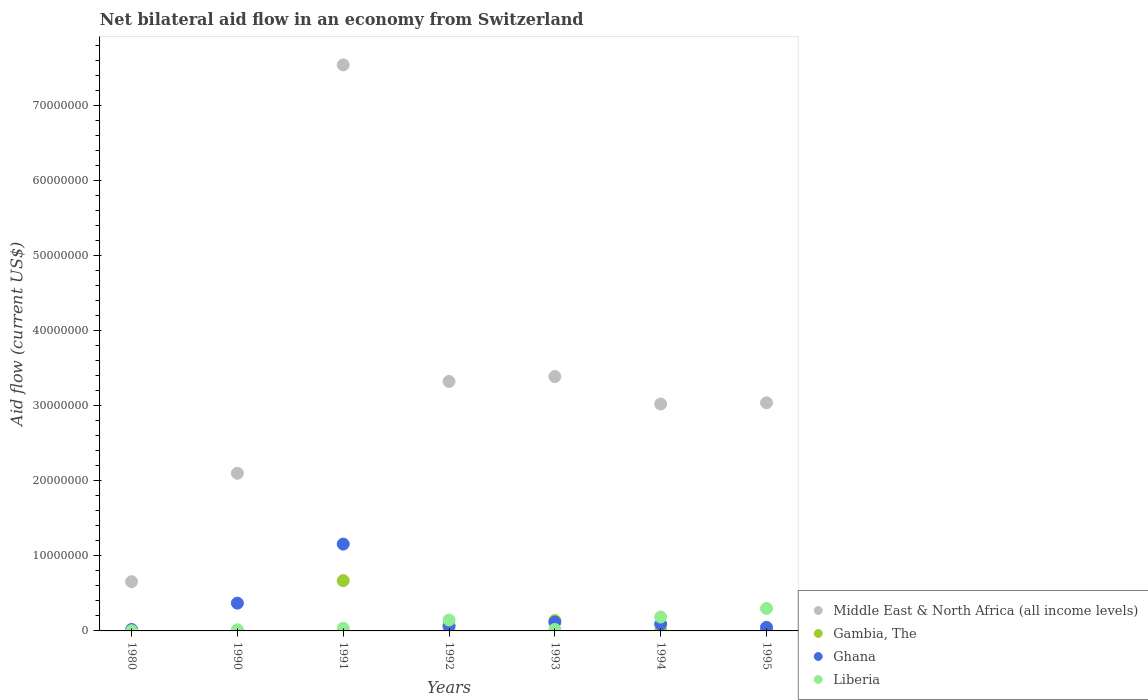Across all years, what is the maximum net bilateral aid flow in Ghana?
Keep it short and to the point. 1.16e+07. Across all years, what is the minimum net bilateral aid flow in Middle East & North Africa (all income levels)?
Your response must be concise. 6.56e+06. What is the total net bilateral aid flow in Middle East & North Africa (all income levels) in the graph?
Ensure brevity in your answer.  2.31e+08. What is the difference between the net bilateral aid flow in Gambia, The in 1980 and that in 1993?
Give a very brief answer. -1.36e+06. What is the difference between the net bilateral aid flow in Middle East & North Africa (all income levels) in 1991 and the net bilateral aid flow in Ghana in 1990?
Provide a short and direct response. 7.17e+07. What is the average net bilateral aid flow in Ghana per year?
Ensure brevity in your answer.  2.67e+06. In the year 1990, what is the difference between the net bilateral aid flow in Ghana and net bilateral aid flow in Gambia, The?
Offer a terse response. 3.66e+06. Is the difference between the net bilateral aid flow in Ghana in 1980 and 1992 greater than the difference between the net bilateral aid flow in Gambia, The in 1980 and 1992?
Your response must be concise. No. What is the difference between the highest and the second highest net bilateral aid flow in Middle East & North Africa (all income levels)?
Offer a terse response. 4.15e+07. What is the difference between the highest and the lowest net bilateral aid flow in Liberia?
Your response must be concise. 2.97e+06. In how many years, is the net bilateral aid flow in Gambia, The greater than the average net bilateral aid flow in Gambia, The taken over all years?
Provide a succinct answer. 2. Is it the case that in every year, the sum of the net bilateral aid flow in Ghana and net bilateral aid flow in Middle East & North Africa (all income levels)  is greater than the sum of net bilateral aid flow in Gambia, The and net bilateral aid flow in Liberia?
Offer a very short reply. Yes. Does the net bilateral aid flow in Liberia monotonically increase over the years?
Keep it short and to the point. No. Is the net bilateral aid flow in Gambia, The strictly less than the net bilateral aid flow in Middle East & North Africa (all income levels) over the years?
Provide a succinct answer. Yes. Are the values on the major ticks of Y-axis written in scientific E-notation?
Keep it short and to the point. No. Does the graph contain any zero values?
Your response must be concise. No. Where does the legend appear in the graph?
Keep it short and to the point. Bottom right. What is the title of the graph?
Keep it short and to the point. Net bilateral aid flow in an economy from Switzerland. Does "Brazil" appear as one of the legend labels in the graph?
Provide a short and direct response. No. What is the label or title of the X-axis?
Make the answer very short. Years. What is the label or title of the Y-axis?
Keep it short and to the point. Aid flow (current US$). What is the Aid flow (current US$) in Middle East & North Africa (all income levels) in 1980?
Your answer should be very brief. 6.56e+06. What is the Aid flow (current US$) of Gambia, The in 1980?
Your answer should be very brief. 2.00e+04. What is the Aid flow (current US$) in Liberia in 1980?
Give a very brief answer. 2.00e+04. What is the Aid flow (current US$) in Middle East & North Africa (all income levels) in 1990?
Your response must be concise. 2.10e+07. What is the Aid flow (current US$) of Ghana in 1990?
Your answer should be compact. 3.70e+06. What is the Aid flow (current US$) in Middle East & North Africa (all income levels) in 1991?
Ensure brevity in your answer.  7.54e+07. What is the Aid flow (current US$) of Gambia, The in 1991?
Offer a very short reply. 6.70e+06. What is the Aid flow (current US$) in Ghana in 1991?
Provide a short and direct response. 1.16e+07. What is the Aid flow (current US$) in Liberia in 1991?
Your answer should be very brief. 3.50e+05. What is the Aid flow (current US$) in Middle East & North Africa (all income levels) in 1992?
Your answer should be compact. 3.32e+07. What is the Aid flow (current US$) of Gambia, The in 1992?
Ensure brevity in your answer.  5.10e+05. What is the Aid flow (current US$) of Ghana in 1992?
Ensure brevity in your answer.  6.80e+05. What is the Aid flow (current US$) of Liberia in 1992?
Your answer should be compact. 1.45e+06. What is the Aid flow (current US$) in Middle East & North Africa (all income levels) in 1993?
Offer a very short reply. 3.39e+07. What is the Aid flow (current US$) of Gambia, The in 1993?
Give a very brief answer. 1.38e+06. What is the Aid flow (current US$) in Ghana in 1993?
Offer a terse response. 1.18e+06. What is the Aid flow (current US$) in Liberia in 1993?
Your answer should be compact. 1.90e+05. What is the Aid flow (current US$) in Middle East & North Africa (all income levels) in 1994?
Offer a very short reply. 3.02e+07. What is the Aid flow (current US$) in Ghana in 1994?
Offer a very short reply. 9.00e+05. What is the Aid flow (current US$) of Liberia in 1994?
Make the answer very short. 1.85e+06. What is the Aid flow (current US$) of Middle East & North Africa (all income levels) in 1995?
Provide a succinct answer. 3.04e+07. What is the Aid flow (current US$) of Ghana in 1995?
Provide a short and direct response. 4.80e+05. What is the Aid flow (current US$) in Liberia in 1995?
Offer a terse response. 2.99e+06. Across all years, what is the maximum Aid flow (current US$) in Middle East & North Africa (all income levels)?
Provide a short and direct response. 7.54e+07. Across all years, what is the maximum Aid flow (current US$) in Gambia, The?
Give a very brief answer. 6.70e+06. Across all years, what is the maximum Aid flow (current US$) in Ghana?
Offer a very short reply. 1.16e+07. Across all years, what is the maximum Aid flow (current US$) of Liberia?
Your response must be concise. 2.99e+06. Across all years, what is the minimum Aid flow (current US$) in Middle East & North Africa (all income levels)?
Give a very brief answer. 6.56e+06. Across all years, what is the minimum Aid flow (current US$) of Gambia, The?
Give a very brief answer. 2.00e+04. Across all years, what is the minimum Aid flow (current US$) in Ghana?
Keep it short and to the point. 1.90e+05. Across all years, what is the minimum Aid flow (current US$) in Liberia?
Keep it short and to the point. 2.00e+04. What is the total Aid flow (current US$) in Middle East & North Africa (all income levels) in the graph?
Keep it short and to the point. 2.31e+08. What is the total Aid flow (current US$) of Gambia, The in the graph?
Your response must be concise. 8.74e+06. What is the total Aid flow (current US$) of Ghana in the graph?
Your answer should be compact. 1.87e+07. What is the total Aid flow (current US$) of Liberia in the graph?
Your answer should be compact. 7.00e+06. What is the difference between the Aid flow (current US$) of Middle East & North Africa (all income levels) in 1980 and that in 1990?
Give a very brief answer. -1.44e+07. What is the difference between the Aid flow (current US$) in Ghana in 1980 and that in 1990?
Offer a very short reply. -3.51e+06. What is the difference between the Aid flow (current US$) of Middle East & North Africa (all income levels) in 1980 and that in 1991?
Offer a terse response. -6.89e+07. What is the difference between the Aid flow (current US$) in Gambia, The in 1980 and that in 1991?
Your answer should be very brief. -6.68e+06. What is the difference between the Aid flow (current US$) of Ghana in 1980 and that in 1991?
Ensure brevity in your answer.  -1.14e+07. What is the difference between the Aid flow (current US$) in Liberia in 1980 and that in 1991?
Your answer should be compact. -3.30e+05. What is the difference between the Aid flow (current US$) of Middle East & North Africa (all income levels) in 1980 and that in 1992?
Give a very brief answer. -2.67e+07. What is the difference between the Aid flow (current US$) of Gambia, The in 1980 and that in 1992?
Offer a very short reply. -4.90e+05. What is the difference between the Aid flow (current US$) of Ghana in 1980 and that in 1992?
Your response must be concise. -4.90e+05. What is the difference between the Aid flow (current US$) in Liberia in 1980 and that in 1992?
Offer a terse response. -1.43e+06. What is the difference between the Aid flow (current US$) in Middle East & North Africa (all income levels) in 1980 and that in 1993?
Your response must be concise. -2.73e+07. What is the difference between the Aid flow (current US$) of Gambia, The in 1980 and that in 1993?
Offer a very short reply. -1.36e+06. What is the difference between the Aid flow (current US$) in Ghana in 1980 and that in 1993?
Your answer should be very brief. -9.90e+05. What is the difference between the Aid flow (current US$) in Middle East & North Africa (all income levels) in 1980 and that in 1994?
Your answer should be compact. -2.37e+07. What is the difference between the Aid flow (current US$) in Gambia, The in 1980 and that in 1994?
Make the answer very short. -2.00e+04. What is the difference between the Aid flow (current US$) in Ghana in 1980 and that in 1994?
Your response must be concise. -7.10e+05. What is the difference between the Aid flow (current US$) in Liberia in 1980 and that in 1994?
Offer a very short reply. -1.83e+06. What is the difference between the Aid flow (current US$) in Middle East & North Africa (all income levels) in 1980 and that in 1995?
Provide a succinct answer. -2.38e+07. What is the difference between the Aid flow (current US$) of Ghana in 1980 and that in 1995?
Ensure brevity in your answer.  -2.90e+05. What is the difference between the Aid flow (current US$) in Liberia in 1980 and that in 1995?
Offer a terse response. -2.97e+06. What is the difference between the Aid flow (current US$) of Middle East & North Africa (all income levels) in 1990 and that in 1991?
Give a very brief answer. -5.44e+07. What is the difference between the Aid flow (current US$) of Gambia, The in 1990 and that in 1991?
Give a very brief answer. -6.66e+06. What is the difference between the Aid flow (current US$) in Ghana in 1990 and that in 1991?
Keep it short and to the point. -7.87e+06. What is the difference between the Aid flow (current US$) of Middle East & North Africa (all income levels) in 1990 and that in 1992?
Offer a terse response. -1.22e+07. What is the difference between the Aid flow (current US$) of Gambia, The in 1990 and that in 1992?
Offer a terse response. -4.70e+05. What is the difference between the Aid flow (current US$) of Ghana in 1990 and that in 1992?
Provide a succinct answer. 3.02e+06. What is the difference between the Aid flow (current US$) in Liberia in 1990 and that in 1992?
Provide a short and direct response. -1.30e+06. What is the difference between the Aid flow (current US$) in Middle East & North Africa (all income levels) in 1990 and that in 1993?
Ensure brevity in your answer.  -1.29e+07. What is the difference between the Aid flow (current US$) of Gambia, The in 1990 and that in 1993?
Your answer should be very brief. -1.34e+06. What is the difference between the Aid flow (current US$) of Ghana in 1990 and that in 1993?
Your answer should be very brief. 2.52e+06. What is the difference between the Aid flow (current US$) of Liberia in 1990 and that in 1993?
Ensure brevity in your answer.  -4.00e+04. What is the difference between the Aid flow (current US$) of Middle East & North Africa (all income levels) in 1990 and that in 1994?
Keep it short and to the point. -9.22e+06. What is the difference between the Aid flow (current US$) in Ghana in 1990 and that in 1994?
Your response must be concise. 2.80e+06. What is the difference between the Aid flow (current US$) in Liberia in 1990 and that in 1994?
Offer a very short reply. -1.70e+06. What is the difference between the Aid flow (current US$) of Middle East & North Africa (all income levels) in 1990 and that in 1995?
Keep it short and to the point. -9.39e+06. What is the difference between the Aid flow (current US$) in Ghana in 1990 and that in 1995?
Your answer should be very brief. 3.22e+06. What is the difference between the Aid flow (current US$) in Liberia in 1990 and that in 1995?
Keep it short and to the point. -2.84e+06. What is the difference between the Aid flow (current US$) in Middle East & North Africa (all income levels) in 1991 and that in 1992?
Keep it short and to the point. 4.22e+07. What is the difference between the Aid flow (current US$) of Gambia, The in 1991 and that in 1992?
Give a very brief answer. 6.19e+06. What is the difference between the Aid flow (current US$) of Ghana in 1991 and that in 1992?
Your response must be concise. 1.09e+07. What is the difference between the Aid flow (current US$) of Liberia in 1991 and that in 1992?
Offer a terse response. -1.10e+06. What is the difference between the Aid flow (current US$) of Middle East & North Africa (all income levels) in 1991 and that in 1993?
Your response must be concise. 4.15e+07. What is the difference between the Aid flow (current US$) in Gambia, The in 1991 and that in 1993?
Keep it short and to the point. 5.32e+06. What is the difference between the Aid flow (current US$) of Ghana in 1991 and that in 1993?
Ensure brevity in your answer.  1.04e+07. What is the difference between the Aid flow (current US$) of Middle East & North Africa (all income levels) in 1991 and that in 1994?
Give a very brief answer. 4.52e+07. What is the difference between the Aid flow (current US$) of Gambia, The in 1991 and that in 1994?
Offer a terse response. 6.66e+06. What is the difference between the Aid flow (current US$) in Ghana in 1991 and that in 1994?
Keep it short and to the point. 1.07e+07. What is the difference between the Aid flow (current US$) in Liberia in 1991 and that in 1994?
Offer a very short reply. -1.50e+06. What is the difference between the Aid flow (current US$) in Middle East & North Africa (all income levels) in 1991 and that in 1995?
Offer a terse response. 4.50e+07. What is the difference between the Aid flow (current US$) in Gambia, The in 1991 and that in 1995?
Provide a succinct answer. 6.65e+06. What is the difference between the Aid flow (current US$) in Ghana in 1991 and that in 1995?
Ensure brevity in your answer.  1.11e+07. What is the difference between the Aid flow (current US$) of Liberia in 1991 and that in 1995?
Provide a short and direct response. -2.64e+06. What is the difference between the Aid flow (current US$) in Middle East & North Africa (all income levels) in 1992 and that in 1993?
Offer a terse response. -6.50e+05. What is the difference between the Aid flow (current US$) of Gambia, The in 1992 and that in 1993?
Ensure brevity in your answer.  -8.70e+05. What is the difference between the Aid flow (current US$) of Ghana in 1992 and that in 1993?
Provide a succinct answer. -5.00e+05. What is the difference between the Aid flow (current US$) of Liberia in 1992 and that in 1993?
Give a very brief answer. 1.26e+06. What is the difference between the Aid flow (current US$) in Middle East & North Africa (all income levels) in 1992 and that in 1994?
Offer a terse response. 3.01e+06. What is the difference between the Aid flow (current US$) in Gambia, The in 1992 and that in 1994?
Keep it short and to the point. 4.70e+05. What is the difference between the Aid flow (current US$) in Liberia in 1992 and that in 1994?
Offer a terse response. -4.00e+05. What is the difference between the Aid flow (current US$) in Middle East & North Africa (all income levels) in 1992 and that in 1995?
Give a very brief answer. 2.84e+06. What is the difference between the Aid flow (current US$) of Gambia, The in 1992 and that in 1995?
Make the answer very short. 4.60e+05. What is the difference between the Aid flow (current US$) in Liberia in 1992 and that in 1995?
Provide a short and direct response. -1.54e+06. What is the difference between the Aid flow (current US$) in Middle East & North Africa (all income levels) in 1993 and that in 1994?
Your response must be concise. 3.66e+06. What is the difference between the Aid flow (current US$) in Gambia, The in 1993 and that in 1994?
Your answer should be compact. 1.34e+06. What is the difference between the Aid flow (current US$) of Liberia in 1993 and that in 1994?
Offer a very short reply. -1.66e+06. What is the difference between the Aid flow (current US$) in Middle East & North Africa (all income levels) in 1993 and that in 1995?
Provide a short and direct response. 3.49e+06. What is the difference between the Aid flow (current US$) in Gambia, The in 1993 and that in 1995?
Make the answer very short. 1.33e+06. What is the difference between the Aid flow (current US$) of Ghana in 1993 and that in 1995?
Provide a succinct answer. 7.00e+05. What is the difference between the Aid flow (current US$) of Liberia in 1993 and that in 1995?
Your answer should be compact. -2.80e+06. What is the difference between the Aid flow (current US$) in Middle East & North Africa (all income levels) in 1994 and that in 1995?
Keep it short and to the point. -1.70e+05. What is the difference between the Aid flow (current US$) of Liberia in 1994 and that in 1995?
Keep it short and to the point. -1.14e+06. What is the difference between the Aid flow (current US$) of Middle East & North Africa (all income levels) in 1980 and the Aid flow (current US$) of Gambia, The in 1990?
Your answer should be compact. 6.52e+06. What is the difference between the Aid flow (current US$) of Middle East & North Africa (all income levels) in 1980 and the Aid flow (current US$) of Ghana in 1990?
Provide a succinct answer. 2.86e+06. What is the difference between the Aid flow (current US$) of Middle East & North Africa (all income levels) in 1980 and the Aid flow (current US$) of Liberia in 1990?
Offer a terse response. 6.41e+06. What is the difference between the Aid flow (current US$) of Gambia, The in 1980 and the Aid flow (current US$) of Ghana in 1990?
Your answer should be compact. -3.68e+06. What is the difference between the Aid flow (current US$) of Gambia, The in 1980 and the Aid flow (current US$) of Liberia in 1990?
Ensure brevity in your answer.  -1.30e+05. What is the difference between the Aid flow (current US$) in Middle East & North Africa (all income levels) in 1980 and the Aid flow (current US$) in Gambia, The in 1991?
Provide a succinct answer. -1.40e+05. What is the difference between the Aid flow (current US$) of Middle East & North Africa (all income levels) in 1980 and the Aid flow (current US$) of Ghana in 1991?
Make the answer very short. -5.01e+06. What is the difference between the Aid flow (current US$) in Middle East & North Africa (all income levels) in 1980 and the Aid flow (current US$) in Liberia in 1991?
Provide a succinct answer. 6.21e+06. What is the difference between the Aid flow (current US$) in Gambia, The in 1980 and the Aid flow (current US$) in Ghana in 1991?
Provide a succinct answer. -1.16e+07. What is the difference between the Aid flow (current US$) in Gambia, The in 1980 and the Aid flow (current US$) in Liberia in 1991?
Provide a short and direct response. -3.30e+05. What is the difference between the Aid flow (current US$) of Middle East & North Africa (all income levels) in 1980 and the Aid flow (current US$) of Gambia, The in 1992?
Your answer should be compact. 6.05e+06. What is the difference between the Aid flow (current US$) of Middle East & North Africa (all income levels) in 1980 and the Aid flow (current US$) of Ghana in 1992?
Keep it short and to the point. 5.88e+06. What is the difference between the Aid flow (current US$) in Middle East & North Africa (all income levels) in 1980 and the Aid flow (current US$) in Liberia in 1992?
Ensure brevity in your answer.  5.11e+06. What is the difference between the Aid flow (current US$) of Gambia, The in 1980 and the Aid flow (current US$) of Ghana in 1992?
Offer a terse response. -6.60e+05. What is the difference between the Aid flow (current US$) of Gambia, The in 1980 and the Aid flow (current US$) of Liberia in 1992?
Your answer should be very brief. -1.43e+06. What is the difference between the Aid flow (current US$) of Ghana in 1980 and the Aid flow (current US$) of Liberia in 1992?
Your answer should be very brief. -1.26e+06. What is the difference between the Aid flow (current US$) in Middle East & North Africa (all income levels) in 1980 and the Aid flow (current US$) in Gambia, The in 1993?
Provide a short and direct response. 5.18e+06. What is the difference between the Aid flow (current US$) of Middle East & North Africa (all income levels) in 1980 and the Aid flow (current US$) of Ghana in 1993?
Your response must be concise. 5.38e+06. What is the difference between the Aid flow (current US$) of Middle East & North Africa (all income levels) in 1980 and the Aid flow (current US$) of Liberia in 1993?
Ensure brevity in your answer.  6.37e+06. What is the difference between the Aid flow (current US$) of Gambia, The in 1980 and the Aid flow (current US$) of Ghana in 1993?
Your answer should be very brief. -1.16e+06. What is the difference between the Aid flow (current US$) of Middle East & North Africa (all income levels) in 1980 and the Aid flow (current US$) of Gambia, The in 1994?
Offer a terse response. 6.52e+06. What is the difference between the Aid flow (current US$) in Middle East & North Africa (all income levels) in 1980 and the Aid flow (current US$) in Ghana in 1994?
Offer a very short reply. 5.66e+06. What is the difference between the Aid flow (current US$) of Middle East & North Africa (all income levels) in 1980 and the Aid flow (current US$) of Liberia in 1994?
Make the answer very short. 4.71e+06. What is the difference between the Aid flow (current US$) in Gambia, The in 1980 and the Aid flow (current US$) in Ghana in 1994?
Provide a short and direct response. -8.80e+05. What is the difference between the Aid flow (current US$) in Gambia, The in 1980 and the Aid flow (current US$) in Liberia in 1994?
Keep it short and to the point. -1.83e+06. What is the difference between the Aid flow (current US$) of Ghana in 1980 and the Aid flow (current US$) of Liberia in 1994?
Offer a terse response. -1.66e+06. What is the difference between the Aid flow (current US$) of Middle East & North Africa (all income levels) in 1980 and the Aid flow (current US$) of Gambia, The in 1995?
Make the answer very short. 6.51e+06. What is the difference between the Aid flow (current US$) of Middle East & North Africa (all income levels) in 1980 and the Aid flow (current US$) of Ghana in 1995?
Ensure brevity in your answer.  6.08e+06. What is the difference between the Aid flow (current US$) of Middle East & North Africa (all income levels) in 1980 and the Aid flow (current US$) of Liberia in 1995?
Offer a very short reply. 3.57e+06. What is the difference between the Aid flow (current US$) of Gambia, The in 1980 and the Aid flow (current US$) of Ghana in 1995?
Provide a short and direct response. -4.60e+05. What is the difference between the Aid flow (current US$) of Gambia, The in 1980 and the Aid flow (current US$) of Liberia in 1995?
Make the answer very short. -2.97e+06. What is the difference between the Aid flow (current US$) of Ghana in 1980 and the Aid flow (current US$) of Liberia in 1995?
Your answer should be compact. -2.80e+06. What is the difference between the Aid flow (current US$) in Middle East & North Africa (all income levels) in 1990 and the Aid flow (current US$) in Gambia, The in 1991?
Offer a very short reply. 1.43e+07. What is the difference between the Aid flow (current US$) in Middle East & North Africa (all income levels) in 1990 and the Aid flow (current US$) in Ghana in 1991?
Offer a very short reply. 9.44e+06. What is the difference between the Aid flow (current US$) in Middle East & North Africa (all income levels) in 1990 and the Aid flow (current US$) in Liberia in 1991?
Offer a terse response. 2.07e+07. What is the difference between the Aid flow (current US$) of Gambia, The in 1990 and the Aid flow (current US$) of Ghana in 1991?
Provide a succinct answer. -1.15e+07. What is the difference between the Aid flow (current US$) in Gambia, The in 1990 and the Aid flow (current US$) in Liberia in 1991?
Ensure brevity in your answer.  -3.10e+05. What is the difference between the Aid flow (current US$) in Ghana in 1990 and the Aid flow (current US$) in Liberia in 1991?
Offer a terse response. 3.35e+06. What is the difference between the Aid flow (current US$) in Middle East & North Africa (all income levels) in 1990 and the Aid flow (current US$) in Gambia, The in 1992?
Make the answer very short. 2.05e+07. What is the difference between the Aid flow (current US$) in Middle East & North Africa (all income levels) in 1990 and the Aid flow (current US$) in Ghana in 1992?
Your answer should be compact. 2.03e+07. What is the difference between the Aid flow (current US$) of Middle East & North Africa (all income levels) in 1990 and the Aid flow (current US$) of Liberia in 1992?
Give a very brief answer. 1.96e+07. What is the difference between the Aid flow (current US$) in Gambia, The in 1990 and the Aid flow (current US$) in Ghana in 1992?
Your response must be concise. -6.40e+05. What is the difference between the Aid flow (current US$) in Gambia, The in 1990 and the Aid flow (current US$) in Liberia in 1992?
Your answer should be compact. -1.41e+06. What is the difference between the Aid flow (current US$) in Ghana in 1990 and the Aid flow (current US$) in Liberia in 1992?
Make the answer very short. 2.25e+06. What is the difference between the Aid flow (current US$) in Middle East & North Africa (all income levels) in 1990 and the Aid flow (current US$) in Gambia, The in 1993?
Your answer should be very brief. 1.96e+07. What is the difference between the Aid flow (current US$) in Middle East & North Africa (all income levels) in 1990 and the Aid flow (current US$) in Ghana in 1993?
Provide a succinct answer. 1.98e+07. What is the difference between the Aid flow (current US$) of Middle East & North Africa (all income levels) in 1990 and the Aid flow (current US$) of Liberia in 1993?
Make the answer very short. 2.08e+07. What is the difference between the Aid flow (current US$) of Gambia, The in 1990 and the Aid flow (current US$) of Ghana in 1993?
Provide a short and direct response. -1.14e+06. What is the difference between the Aid flow (current US$) of Ghana in 1990 and the Aid flow (current US$) of Liberia in 1993?
Your response must be concise. 3.51e+06. What is the difference between the Aid flow (current US$) in Middle East & North Africa (all income levels) in 1990 and the Aid flow (current US$) in Gambia, The in 1994?
Provide a succinct answer. 2.10e+07. What is the difference between the Aid flow (current US$) in Middle East & North Africa (all income levels) in 1990 and the Aid flow (current US$) in Ghana in 1994?
Make the answer very short. 2.01e+07. What is the difference between the Aid flow (current US$) in Middle East & North Africa (all income levels) in 1990 and the Aid flow (current US$) in Liberia in 1994?
Make the answer very short. 1.92e+07. What is the difference between the Aid flow (current US$) of Gambia, The in 1990 and the Aid flow (current US$) of Ghana in 1994?
Give a very brief answer. -8.60e+05. What is the difference between the Aid flow (current US$) of Gambia, The in 1990 and the Aid flow (current US$) of Liberia in 1994?
Make the answer very short. -1.81e+06. What is the difference between the Aid flow (current US$) in Ghana in 1990 and the Aid flow (current US$) in Liberia in 1994?
Offer a terse response. 1.85e+06. What is the difference between the Aid flow (current US$) of Middle East & North Africa (all income levels) in 1990 and the Aid flow (current US$) of Gambia, The in 1995?
Your answer should be compact. 2.10e+07. What is the difference between the Aid flow (current US$) in Middle East & North Africa (all income levels) in 1990 and the Aid flow (current US$) in Ghana in 1995?
Make the answer very short. 2.05e+07. What is the difference between the Aid flow (current US$) of Middle East & North Africa (all income levels) in 1990 and the Aid flow (current US$) of Liberia in 1995?
Offer a terse response. 1.80e+07. What is the difference between the Aid flow (current US$) of Gambia, The in 1990 and the Aid flow (current US$) of Ghana in 1995?
Your answer should be very brief. -4.40e+05. What is the difference between the Aid flow (current US$) of Gambia, The in 1990 and the Aid flow (current US$) of Liberia in 1995?
Provide a succinct answer. -2.95e+06. What is the difference between the Aid flow (current US$) of Ghana in 1990 and the Aid flow (current US$) of Liberia in 1995?
Your answer should be compact. 7.10e+05. What is the difference between the Aid flow (current US$) in Middle East & North Africa (all income levels) in 1991 and the Aid flow (current US$) in Gambia, The in 1992?
Your answer should be compact. 7.49e+07. What is the difference between the Aid flow (current US$) in Middle East & North Africa (all income levels) in 1991 and the Aid flow (current US$) in Ghana in 1992?
Ensure brevity in your answer.  7.47e+07. What is the difference between the Aid flow (current US$) in Middle East & North Africa (all income levels) in 1991 and the Aid flow (current US$) in Liberia in 1992?
Offer a terse response. 7.40e+07. What is the difference between the Aid flow (current US$) of Gambia, The in 1991 and the Aid flow (current US$) of Ghana in 1992?
Provide a short and direct response. 6.02e+06. What is the difference between the Aid flow (current US$) of Gambia, The in 1991 and the Aid flow (current US$) of Liberia in 1992?
Make the answer very short. 5.25e+06. What is the difference between the Aid flow (current US$) in Ghana in 1991 and the Aid flow (current US$) in Liberia in 1992?
Keep it short and to the point. 1.01e+07. What is the difference between the Aid flow (current US$) in Middle East & North Africa (all income levels) in 1991 and the Aid flow (current US$) in Gambia, The in 1993?
Ensure brevity in your answer.  7.40e+07. What is the difference between the Aid flow (current US$) in Middle East & North Africa (all income levels) in 1991 and the Aid flow (current US$) in Ghana in 1993?
Ensure brevity in your answer.  7.42e+07. What is the difference between the Aid flow (current US$) in Middle East & North Africa (all income levels) in 1991 and the Aid flow (current US$) in Liberia in 1993?
Keep it short and to the point. 7.52e+07. What is the difference between the Aid flow (current US$) of Gambia, The in 1991 and the Aid flow (current US$) of Ghana in 1993?
Offer a very short reply. 5.52e+06. What is the difference between the Aid flow (current US$) in Gambia, The in 1991 and the Aid flow (current US$) in Liberia in 1993?
Make the answer very short. 6.51e+06. What is the difference between the Aid flow (current US$) in Ghana in 1991 and the Aid flow (current US$) in Liberia in 1993?
Your answer should be compact. 1.14e+07. What is the difference between the Aid flow (current US$) in Middle East & North Africa (all income levels) in 1991 and the Aid flow (current US$) in Gambia, The in 1994?
Ensure brevity in your answer.  7.54e+07. What is the difference between the Aid flow (current US$) of Middle East & North Africa (all income levels) in 1991 and the Aid flow (current US$) of Ghana in 1994?
Ensure brevity in your answer.  7.45e+07. What is the difference between the Aid flow (current US$) of Middle East & North Africa (all income levels) in 1991 and the Aid flow (current US$) of Liberia in 1994?
Offer a terse response. 7.36e+07. What is the difference between the Aid flow (current US$) in Gambia, The in 1991 and the Aid flow (current US$) in Ghana in 1994?
Your response must be concise. 5.80e+06. What is the difference between the Aid flow (current US$) of Gambia, The in 1991 and the Aid flow (current US$) of Liberia in 1994?
Provide a succinct answer. 4.85e+06. What is the difference between the Aid flow (current US$) of Ghana in 1991 and the Aid flow (current US$) of Liberia in 1994?
Make the answer very short. 9.72e+06. What is the difference between the Aid flow (current US$) in Middle East & North Africa (all income levels) in 1991 and the Aid flow (current US$) in Gambia, The in 1995?
Your answer should be compact. 7.54e+07. What is the difference between the Aid flow (current US$) of Middle East & North Africa (all income levels) in 1991 and the Aid flow (current US$) of Ghana in 1995?
Make the answer very short. 7.49e+07. What is the difference between the Aid flow (current US$) of Middle East & North Africa (all income levels) in 1991 and the Aid flow (current US$) of Liberia in 1995?
Offer a very short reply. 7.24e+07. What is the difference between the Aid flow (current US$) in Gambia, The in 1991 and the Aid flow (current US$) in Ghana in 1995?
Provide a succinct answer. 6.22e+06. What is the difference between the Aid flow (current US$) in Gambia, The in 1991 and the Aid flow (current US$) in Liberia in 1995?
Provide a short and direct response. 3.71e+06. What is the difference between the Aid flow (current US$) in Ghana in 1991 and the Aid flow (current US$) in Liberia in 1995?
Provide a short and direct response. 8.58e+06. What is the difference between the Aid flow (current US$) in Middle East & North Africa (all income levels) in 1992 and the Aid flow (current US$) in Gambia, The in 1993?
Offer a terse response. 3.19e+07. What is the difference between the Aid flow (current US$) in Middle East & North Africa (all income levels) in 1992 and the Aid flow (current US$) in Ghana in 1993?
Your answer should be very brief. 3.21e+07. What is the difference between the Aid flow (current US$) in Middle East & North Africa (all income levels) in 1992 and the Aid flow (current US$) in Liberia in 1993?
Your answer should be compact. 3.30e+07. What is the difference between the Aid flow (current US$) of Gambia, The in 1992 and the Aid flow (current US$) of Ghana in 1993?
Give a very brief answer. -6.70e+05. What is the difference between the Aid flow (current US$) of Gambia, The in 1992 and the Aid flow (current US$) of Liberia in 1993?
Provide a short and direct response. 3.20e+05. What is the difference between the Aid flow (current US$) in Ghana in 1992 and the Aid flow (current US$) in Liberia in 1993?
Provide a succinct answer. 4.90e+05. What is the difference between the Aid flow (current US$) in Middle East & North Africa (all income levels) in 1992 and the Aid flow (current US$) in Gambia, The in 1994?
Ensure brevity in your answer.  3.32e+07. What is the difference between the Aid flow (current US$) in Middle East & North Africa (all income levels) in 1992 and the Aid flow (current US$) in Ghana in 1994?
Offer a terse response. 3.23e+07. What is the difference between the Aid flow (current US$) of Middle East & North Africa (all income levels) in 1992 and the Aid flow (current US$) of Liberia in 1994?
Keep it short and to the point. 3.14e+07. What is the difference between the Aid flow (current US$) in Gambia, The in 1992 and the Aid flow (current US$) in Ghana in 1994?
Give a very brief answer. -3.90e+05. What is the difference between the Aid flow (current US$) of Gambia, The in 1992 and the Aid flow (current US$) of Liberia in 1994?
Provide a succinct answer. -1.34e+06. What is the difference between the Aid flow (current US$) of Ghana in 1992 and the Aid flow (current US$) of Liberia in 1994?
Your answer should be compact. -1.17e+06. What is the difference between the Aid flow (current US$) of Middle East & North Africa (all income levels) in 1992 and the Aid flow (current US$) of Gambia, The in 1995?
Make the answer very short. 3.32e+07. What is the difference between the Aid flow (current US$) in Middle East & North Africa (all income levels) in 1992 and the Aid flow (current US$) in Ghana in 1995?
Offer a very short reply. 3.28e+07. What is the difference between the Aid flow (current US$) in Middle East & North Africa (all income levels) in 1992 and the Aid flow (current US$) in Liberia in 1995?
Provide a short and direct response. 3.02e+07. What is the difference between the Aid flow (current US$) in Gambia, The in 1992 and the Aid flow (current US$) in Ghana in 1995?
Ensure brevity in your answer.  3.00e+04. What is the difference between the Aid flow (current US$) in Gambia, The in 1992 and the Aid flow (current US$) in Liberia in 1995?
Give a very brief answer. -2.48e+06. What is the difference between the Aid flow (current US$) of Ghana in 1992 and the Aid flow (current US$) of Liberia in 1995?
Your response must be concise. -2.31e+06. What is the difference between the Aid flow (current US$) in Middle East & North Africa (all income levels) in 1993 and the Aid flow (current US$) in Gambia, The in 1994?
Ensure brevity in your answer.  3.38e+07. What is the difference between the Aid flow (current US$) in Middle East & North Africa (all income levels) in 1993 and the Aid flow (current US$) in Ghana in 1994?
Provide a short and direct response. 3.30e+07. What is the difference between the Aid flow (current US$) of Middle East & North Africa (all income levels) in 1993 and the Aid flow (current US$) of Liberia in 1994?
Provide a succinct answer. 3.20e+07. What is the difference between the Aid flow (current US$) of Gambia, The in 1993 and the Aid flow (current US$) of Liberia in 1994?
Provide a succinct answer. -4.70e+05. What is the difference between the Aid flow (current US$) in Ghana in 1993 and the Aid flow (current US$) in Liberia in 1994?
Your response must be concise. -6.70e+05. What is the difference between the Aid flow (current US$) in Middle East & North Africa (all income levels) in 1993 and the Aid flow (current US$) in Gambia, The in 1995?
Give a very brief answer. 3.38e+07. What is the difference between the Aid flow (current US$) in Middle East & North Africa (all income levels) in 1993 and the Aid flow (current US$) in Ghana in 1995?
Ensure brevity in your answer.  3.34e+07. What is the difference between the Aid flow (current US$) of Middle East & North Africa (all income levels) in 1993 and the Aid flow (current US$) of Liberia in 1995?
Offer a very short reply. 3.09e+07. What is the difference between the Aid flow (current US$) in Gambia, The in 1993 and the Aid flow (current US$) in Liberia in 1995?
Keep it short and to the point. -1.61e+06. What is the difference between the Aid flow (current US$) of Ghana in 1993 and the Aid flow (current US$) of Liberia in 1995?
Ensure brevity in your answer.  -1.81e+06. What is the difference between the Aid flow (current US$) of Middle East & North Africa (all income levels) in 1994 and the Aid flow (current US$) of Gambia, The in 1995?
Give a very brief answer. 3.02e+07. What is the difference between the Aid flow (current US$) in Middle East & North Africa (all income levels) in 1994 and the Aid flow (current US$) in Ghana in 1995?
Offer a terse response. 2.98e+07. What is the difference between the Aid flow (current US$) of Middle East & North Africa (all income levels) in 1994 and the Aid flow (current US$) of Liberia in 1995?
Ensure brevity in your answer.  2.72e+07. What is the difference between the Aid flow (current US$) of Gambia, The in 1994 and the Aid flow (current US$) of Ghana in 1995?
Your answer should be compact. -4.40e+05. What is the difference between the Aid flow (current US$) in Gambia, The in 1994 and the Aid flow (current US$) in Liberia in 1995?
Offer a terse response. -2.95e+06. What is the difference between the Aid flow (current US$) of Ghana in 1994 and the Aid flow (current US$) of Liberia in 1995?
Make the answer very short. -2.09e+06. What is the average Aid flow (current US$) of Middle East & North Africa (all income levels) per year?
Your answer should be very brief. 3.30e+07. What is the average Aid flow (current US$) in Gambia, The per year?
Provide a succinct answer. 1.25e+06. What is the average Aid flow (current US$) in Ghana per year?
Give a very brief answer. 2.67e+06. What is the average Aid flow (current US$) in Liberia per year?
Provide a short and direct response. 1.00e+06. In the year 1980, what is the difference between the Aid flow (current US$) in Middle East & North Africa (all income levels) and Aid flow (current US$) in Gambia, The?
Your response must be concise. 6.54e+06. In the year 1980, what is the difference between the Aid flow (current US$) in Middle East & North Africa (all income levels) and Aid flow (current US$) in Ghana?
Make the answer very short. 6.37e+06. In the year 1980, what is the difference between the Aid flow (current US$) in Middle East & North Africa (all income levels) and Aid flow (current US$) in Liberia?
Your answer should be compact. 6.54e+06. In the year 1980, what is the difference between the Aid flow (current US$) of Gambia, The and Aid flow (current US$) of Liberia?
Offer a terse response. 0. In the year 1990, what is the difference between the Aid flow (current US$) in Middle East & North Africa (all income levels) and Aid flow (current US$) in Gambia, The?
Ensure brevity in your answer.  2.10e+07. In the year 1990, what is the difference between the Aid flow (current US$) in Middle East & North Africa (all income levels) and Aid flow (current US$) in Ghana?
Ensure brevity in your answer.  1.73e+07. In the year 1990, what is the difference between the Aid flow (current US$) in Middle East & North Africa (all income levels) and Aid flow (current US$) in Liberia?
Provide a succinct answer. 2.09e+07. In the year 1990, what is the difference between the Aid flow (current US$) of Gambia, The and Aid flow (current US$) of Ghana?
Provide a short and direct response. -3.66e+06. In the year 1990, what is the difference between the Aid flow (current US$) in Ghana and Aid flow (current US$) in Liberia?
Ensure brevity in your answer.  3.55e+06. In the year 1991, what is the difference between the Aid flow (current US$) of Middle East & North Africa (all income levels) and Aid flow (current US$) of Gambia, The?
Ensure brevity in your answer.  6.87e+07. In the year 1991, what is the difference between the Aid flow (current US$) in Middle East & North Africa (all income levels) and Aid flow (current US$) in Ghana?
Provide a succinct answer. 6.38e+07. In the year 1991, what is the difference between the Aid flow (current US$) in Middle East & North Africa (all income levels) and Aid flow (current US$) in Liberia?
Ensure brevity in your answer.  7.51e+07. In the year 1991, what is the difference between the Aid flow (current US$) of Gambia, The and Aid flow (current US$) of Ghana?
Offer a very short reply. -4.87e+06. In the year 1991, what is the difference between the Aid flow (current US$) in Gambia, The and Aid flow (current US$) in Liberia?
Offer a very short reply. 6.35e+06. In the year 1991, what is the difference between the Aid flow (current US$) in Ghana and Aid flow (current US$) in Liberia?
Make the answer very short. 1.12e+07. In the year 1992, what is the difference between the Aid flow (current US$) of Middle East & North Africa (all income levels) and Aid flow (current US$) of Gambia, The?
Your response must be concise. 3.27e+07. In the year 1992, what is the difference between the Aid flow (current US$) of Middle East & North Africa (all income levels) and Aid flow (current US$) of Ghana?
Offer a very short reply. 3.26e+07. In the year 1992, what is the difference between the Aid flow (current US$) of Middle East & North Africa (all income levels) and Aid flow (current US$) of Liberia?
Ensure brevity in your answer.  3.18e+07. In the year 1992, what is the difference between the Aid flow (current US$) in Gambia, The and Aid flow (current US$) in Liberia?
Provide a succinct answer. -9.40e+05. In the year 1992, what is the difference between the Aid flow (current US$) of Ghana and Aid flow (current US$) of Liberia?
Your answer should be very brief. -7.70e+05. In the year 1993, what is the difference between the Aid flow (current US$) of Middle East & North Africa (all income levels) and Aid flow (current US$) of Gambia, The?
Give a very brief answer. 3.25e+07. In the year 1993, what is the difference between the Aid flow (current US$) of Middle East & North Africa (all income levels) and Aid flow (current US$) of Ghana?
Give a very brief answer. 3.27e+07. In the year 1993, what is the difference between the Aid flow (current US$) of Middle East & North Africa (all income levels) and Aid flow (current US$) of Liberia?
Your answer should be very brief. 3.37e+07. In the year 1993, what is the difference between the Aid flow (current US$) of Gambia, The and Aid flow (current US$) of Liberia?
Your response must be concise. 1.19e+06. In the year 1993, what is the difference between the Aid flow (current US$) of Ghana and Aid flow (current US$) of Liberia?
Give a very brief answer. 9.90e+05. In the year 1994, what is the difference between the Aid flow (current US$) in Middle East & North Africa (all income levels) and Aid flow (current US$) in Gambia, The?
Provide a succinct answer. 3.02e+07. In the year 1994, what is the difference between the Aid flow (current US$) in Middle East & North Africa (all income levels) and Aid flow (current US$) in Ghana?
Keep it short and to the point. 2.93e+07. In the year 1994, what is the difference between the Aid flow (current US$) in Middle East & North Africa (all income levels) and Aid flow (current US$) in Liberia?
Keep it short and to the point. 2.84e+07. In the year 1994, what is the difference between the Aid flow (current US$) in Gambia, The and Aid flow (current US$) in Ghana?
Your response must be concise. -8.60e+05. In the year 1994, what is the difference between the Aid flow (current US$) in Gambia, The and Aid flow (current US$) in Liberia?
Provide a succinct answer. -1.81e+06. In the year 1994, what is the difference between the Aid flow (current US$) of Ghana and Aid flow (current US$) of Liberia?
Offer a very short reply. -9.50e+05. In the year 1995, what is the difference between the Aid flow (current US$) in Middle East & North Africa (all income levels) and Aid flow (current US$) in Gambia, The?
Give a very brief answer. 3.04e+07. In the year 1995, what is the difference between the Aid flow (current US$) of Middle East & North Africa (all income levels) and Aid flow (current US$) of Ghana?
Your response must be concise. 2.99e+07. In the year 1995, what is the difference between the Aid flow (current US$) in Middle East & North Africa (all income levels) and Aid flow (current US$) in Liberia?
Offer a very short reply. 2.74e+07. In the year 1995, what is the difference between the Aid flow (current US$) in Gambia, The and Aid flow (current US$) in Ghana?
Ensure brevity in your answer.  -4.30e+05. In the year 1995, what is the difference between the Aid flow (current US$) of Gambia, The and Aid flow (current US$) of Liberia?
Offer a very short reply. -2.94e+06. In the year 1995, what is the difference between the Aid flow (current US$) of Ghana and Aid flow (current US$) of Liberia?
Provide a succinct answer. -2.51e+06. What is the ratio of the Aid flow (current US$) of Middle East & North Africa (all income levels) in 1980 to that in 1990?
Your answer should be very brief. 0.31. What is the ratio of the Aid flow (current US$) in Gambia, The in 1980 to that in 1990?
Provide a succinct answer. 0.5. What is the ratio of the Aid flow (current US$) of Ghana in 1980 to that in 1990?
Your answer should be compact. 0.05. What is the ratio of the Aid flow (current US$) of Liberia in 1980 to that in 1990?
Offer a very short reply. 0.13. What is the ratio of the Aid flow (current US$) in Middle East & North Africa (all income levels) in 1980 to that in 1991?
Offer a terse response. 0.09. What is the ratio of the Aid flow (current US$) in Gambia, The in 1980 to that in 1991?
Provide a short and direct response. 0. What is the ratio of the Aid flow (current US$) of Ghana in 1980 to that in 1991?
Offer a very short reply. 0.02. What is the ratio of the Aid flow (current US$) in Liberia in 1980 to that in 1991?
Provide a succinct answer. 0.06. What is the ratio of the Aid flow (current US$) of Middle East & North Africa (all income levels) in 1980 to that in 1992?
Ensure brevity in your answer.  0.2. What is the ratio of the Aid flow (current US$) of Gambia, The in 1980 to that in 1992?
Offer a terse response. 0.04. What is the ratio of the Aid flow (current US$) in Ghana in 1980 to that in 1992?
Give a very brief answer. 0.28. What is the ratio of the Aid flow (current US$) in Liberia in 1980 to that in 1992?
Give a very brief answer. 0.01. What is the ratio of the Aid flow (current US$) of Middle East & North Africa (all income levels) in 1980 to that in 1993?
Offer a very short reply. 0.19. What is the ratio of the Aid flow (current US$) of Gambia, The in 1980 to that in 1993?
Offer a very short reply. 0.01. What is the ratio of the Aid flow (current US$) of Ghana in 1980 to that in 1993?
Your answer should be compact. 0.16. What is the ratio of the Aid flow (current US$) in Liberia in 1980 to that in 1993?
Provide a succinct answer. 0.11. What is the ratio of the Aid flow (current US$) of Middle East & North Africa (all income levels) in 1980 to that in 1994?
Ensure brevity in your answer.  0.22. What is the ratio of the Aid flow (current US$) of Gambia, The in 1980 to that in 1994?
Your answer should be very brief. 0.5. What is the ratio of the Aid flow (current US$) in Ghana in 1980 to that in 1994?
Your answer should be compact. 0.21. What is the ratio of the Aid flow (current US$) of Liberia in 1980 to that in 1994?
Offer a terse response. 0.01. What is the ratio of the Aid flow (current US$) in Middle East & North Africa (all income levels) in 1980 to that in 1995?
Provide a short and direct response. 0.22. What is the ratio of the Aid flow (current US$) of Gambia, The in 1980 to that in 1995?
Your answer should be compact. 0.4. What is the ratio of the Aid flow (current US$) in Ghana in 1980 to that in 1995?
Provide a short and direct response. 0.4. What is the ratio of the Aid flow (current US$) of Liberia in 1980 to that in 1995?
Give a very brief answer. 0.01. What is the ratio of the Aid flow (current US$) of Middle East & North Africa (all income levels) in 1990 to that in 1991?
Provide a short and direct response. 0.28. What is the ratio of the Aid flow (current US$) of Gambia, The in 1990 to that in 1991?
Offer a very short reply. 0.01. What is the ratio of the Aid flow (current US$) of Ghana in 1990 to that in 1991?
Provide a short and direct response. 0.32. What is the ratio of the Aid flow (current US$) in Liberia in 1990 to that in 1991?
Your response must be concise. 0.43. What is the ratio of the Aid flow (current US$) of Middle East & North Africa (all income levels) in 1990 to that in 1992?
Give a very brief answer. 0.63. What is the ratio of the Aid flow (current US$) of Gambia, The in 1990 to that in 1992?
Provide a short and direct response. 0.08. What is the ratio of the Aid flow (current US$) of Ghana in 1990 to that in 1992?
Your answer should be very brief. 5.44. What is the ratio of the Aid flow (current US$) of Liberia in 1990 to that in 1992?
Provide a succinct answer. 0.1. What is the ratio of the Aid flow (current US$) of Middle East & North Africa (all income levels) in 1990 to that in 1993?
Your response must be concise. 0.62. What is the ratio of the Aid flow (current US$) of Gambia, The in 1990 to that in 1993?
Keep it short and to the point. 0.03. What is the ratio of the Aid flow (current US$) in Ghana in 1990 to that in 1993?
Give a very brief answer. 3.14. What is the ratio of the Aid flow (current US$) of Liberia in 1990 to that in 1993?
Offer a terse response. 0.79. What is the ratio of the Aid flow (current US$) in Middle East & North Africa (all income levels) in 1990 to that in 1994?
Your answer should be very brief. 0.69. What is the ratio of the Aid flow (current US$) of Ghana in 1990 to that in 1994?
Provide a short and direct response. 4.11. What is the ratio of the Aid flow (current US$) in Liberia in 1990 to that in 1994?
Provide a short and direct response. 0.08. What is the ratio of the Aid flow (current US$) of Middle East & North Africa (all income levels) in 1990 to that in 1995?
Your answer should be compact. 0.69. What is the ratio of the Aid flow (current US$) in Ghana in 1990 to that in 1995?
Your answer should be very brief. 7.71. What is the ratio of the Aid flow (current US$) in Liberia in 1990 to that in 1995?
Keep it short and to the point. 0.05. What is the ratio of the Aid flow (current US$) of Middle East & North Africa (all income levels) in 1991 to that in 1992?
Offer a very short reply. 2.27. What is the ratio of the Aid flow (current US$) of Gambia, The in 1991 to that in 1992?
Keep it short and to the point. 13.14. What is the ratio of the Aid flow (current US$) of Ghana in 1991 to that in 1992?
Offer a terse response. 17.01. What is the ratio of the Aid flow (current US$) in Liberia in 1991 to that in 1992?
Keep it short and to the point. 0.24. What is the ratio of the Aid flow (current US$) in Middle East & North Africa (all income levels) in 1991 to that in 1993?
Ensure brevity in your answer.  2.23. What is the ratio of the Aid flow (current US$) in Gambia, The in 1991 to that in 1993?
Make the answer very short. 4.86. What is the ratio of the Aid flow (current US$) of Ghana in 1991 to that in 1993?
Provide a succinct answer. 9.81. What is the ratio of the Aid flow (current US$) in Liberia in 1991 to that in 1993?
Keep it short and to the point. 1.84. What is the ratio of the Aid flow (current US$) in Middle East & North Africa (all income levels) in 1991 to that in 1994?
Offer a very short reply. 2.49. What is the ratio of the Aid flow (current US$) in Gambia, The in 1991 to that in 1994?
Your answer should be very brief. 167.5. What is the ratio of the Aid flow (current US$) in Ghana in 1991 to that in 1994?
Your answer should be compact. 12.86. What is the ratio of the Aid flow (current US$) in Liberia in 1991 to that in 1994?
Your response must be concise. 0.19. What is the ratio of the Aid flow (current US$) in Middle East & North Africa (all income levels) in 1991 to that in 1995?
Offer a very short reply. 2.48. What is the ratio of the Aid flow (current US$) in Gambia, The in 1991 to that in 1995?
Offer a very short reply. 134. What is the ratio of the Aid flow (current US$) in Ghana in 1991 to that in 1995?
Your response must be concise. 24.1. What is the ratio of the Aid flow (current US$) in Liberia in 1991 to that in 1995?
Your answer should be very brief. 0.12. What is the ratio of the Aid flow (current US$) of Middle East & North Africa (all income levels) in 1992 to that in 1993?
Make the answer very short. 0.98. What is the ratio of the Aid flow (current US$) in Gambia, The in 1992 to that in 1993?
Keep it short and to the point. 0.37. What is the ratio of the Aid flow (current US$) in Ghana in 1992 to that in 1993?
Provide a short and direct response. 0.58. What is the ratio of the Aid flow (current US$) of Liberia in 1992 to that in 1993?
Provide a short and direct response. 7.63. What is the ratio of the Aid flow (current US$) of Middle East & North Africa (all income levels) in 1992 to that in 1994?
Ensure brevity in your answer.  1.1. What is the ratio of the Aid flow (current US$) in Gambia, The in 1992 to that in 1994?
Your answer should be compact. 12.75. What is the ratio of the Aid flow (current US$) of Ghana in 1992 to that in 1994?
Provide a succinct answer. 0.76. What is the ratio of the Aid flow (current US$) in Liberia in 1992 to that in 1994?
Provide a succinct answer. 0.78. What is the ratio of the Aid flow (current US$) of Middle East & North Africa (all income levels) in 1992 to that in 1995?
Give a very brief answer. 1.09. What is the ratio of the Aid flow (current US$) in Ghana in 1992 to that in 1995?
Provide a short and direct response. 1.42. What is the ratio of the Aid flow (current US$) of Liberia in 1992 to that in 1995?
Offer a very short reply. 0.48. What is the ratio of the Aid flow (current US$) in Middle East & North Africa (all income levels) in 1993 to that in 1994?
Ensure brevity in your answer.  1.12. What is the ratio of the Aid flow (current US$) of Gambia, The in 1993 to that in 1994?
Give a very brief answer. 34.5. What is the ratio of the Aid flow (current US$) in Ghana in 1993 to that in 1994?
Offer a very short reply. 1.31. What is the ratio of the Aid flow (current US$) in Liberia in 1993 to that in 1994?
Your answer should be compact. 0.1. What is the ratio of the Aid flow (current US$) of Middle East & North Africa (all income levels) in 1993 to that in 1995?
Your answer should be very brief. 1.11. What is the ratio of the Aid flow (current US$) in Gambia, The in 1993 to that in 1995?
Make the answer very short. 27.6. What is the ratio of the Aid flow (current US$) of Ghana in 1993 to that in 1995?
Your answer should be very brief. 2.46. What is the ratio of the Aid flow (current US$) in Liberia in 1993 to that in 1995?
Offer a terse response. 0.06. What is the ratio of the Aid flow (current US$) in Ghana in 1994 to that in 1995?
Give a very brief answer. 1.88. What is the ratio of the Aid flow (current US$) of Liberia in 1994 to that in 1995?
Your answer should be very brief. 0.62. What is the difference between the highest and the second highest Aid flow (current US$) in Middle East & North Africa (all income levels)?
Offer a terse response. 4.15e+07. What is the difference between the highest and the second highest Aid flow (current US$) in Gambia, The?
Offer a very short reply. 5.32e+06. What is the difference between the highest and the second highest Aid flow (current US$) in Ghana?
Provide a succinct answer. 7.87e+06. What is the difference between the highest and the second highest Aid flow (current US$) in Liberia?
Keep it short and to the point. 1.14e+06. What is the difference between the highest and the lowest Aid flow (current US$) of Middle East & North Africa (all income levels)?
Make the answer very short. 6.89e+07. What is the difference between the highest and the lowest Aid flow (current US$) in Gambia, The?
Provide a short and direct response. 6.68e+06. What is the difference between the highest and the lowest Aid flow (current US$) in Ghana?
Give a very brief answer. 1.14e+07. What is the difference between the highest and the lowest Aid flow (current US$) of Liberia?
Provide a short and direct response. 2.97e+06. 